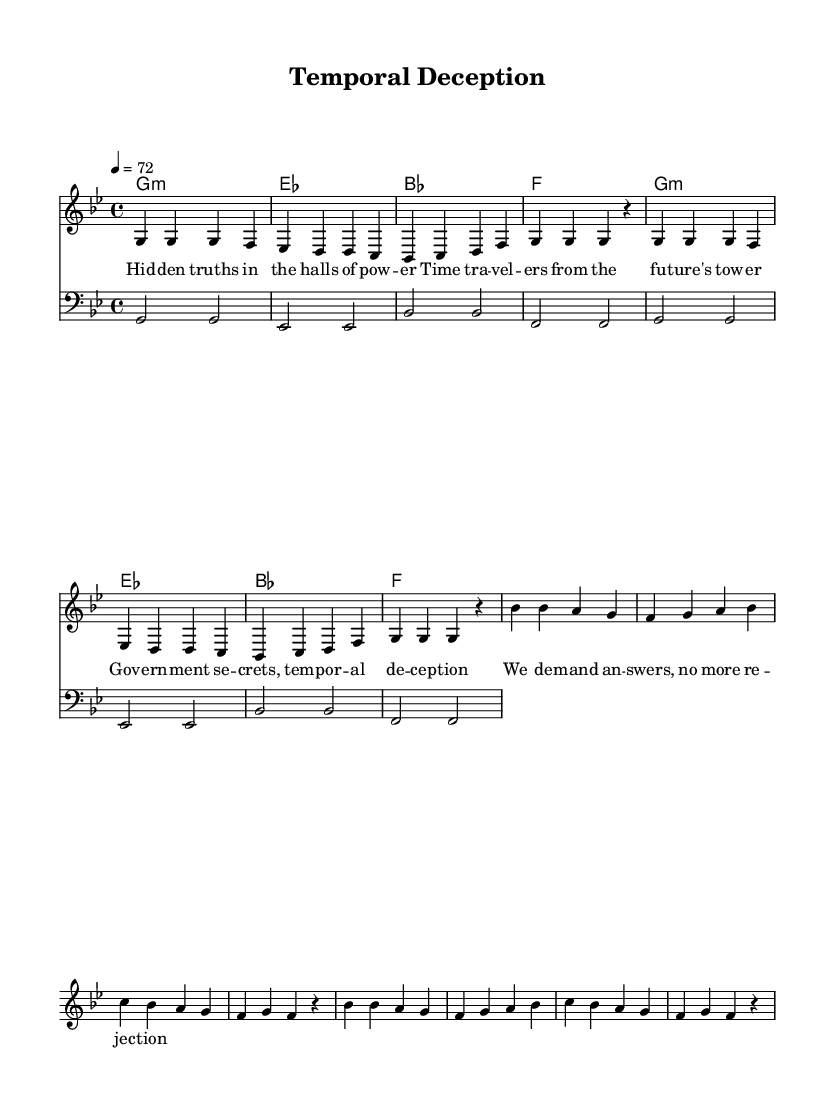What is the key signature of this music? The key signature is identified by the presence of two flats: B-flat and E-flat, indicating it is in G minor.
Answer: G minor What is the time signature? The time signature is displayed prominently at the beginning of the score, indicating each measure has four beats, which is noted as 4/4.
Answer: 4/4 What is the tempo marking? The tempo marking shows "4 = 72," which means there are 72 beats per minute in a quarter note.
Answer: 72 How many measures are in the verse? By counting the number of groupings in the verse section labeled "verseVocal," there are eight measures total.
Answer: 8 What musical genre does this piece represent? The title and lyrics explicitly reference themes characteristic of reggae music, particularly with a spiritual and social commentary element.
Answer: Reggae What is a recurring theme in the lyrics? The lyrics highlight the notion of hidden truths and government secrecy, suggesting a broader theme of political and social awareness.
Answer: Government secrets How is the bass line structured compared to the vocals? The bass line consistently supports the vocal melody, providing a foundation with simple repeated patterns that align with the vocal rhythm, ensuring harmony.
Answer: Foundation 